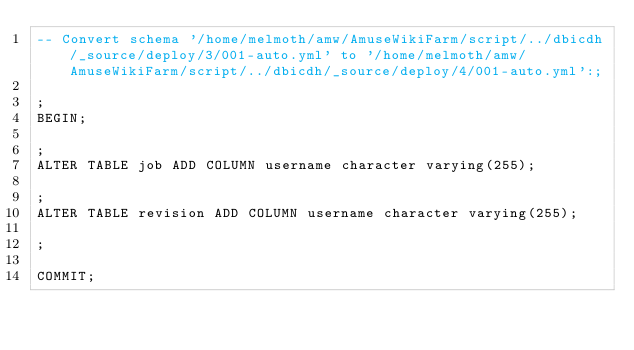<code> <loc_0><loc_0><loc_500><loc_500><_SQL_>-- Convert schema '/home/melmoth/amw/AmuseWikiFarm/script/../dbicdh/_source/deploy/3/001-auto.yml' to '/home/melmoth/amw/AmuseWikiFarm/script/../dbicdh/_source/deploy/4/001-auto.yml':;

;
BEGIN;

;
ALTER TABLE job ADD COLUMN username character varying(255);

;
ALTER TABLE revision ADD COLUMN username character varying(255);

;

COMMIT;

</code> 